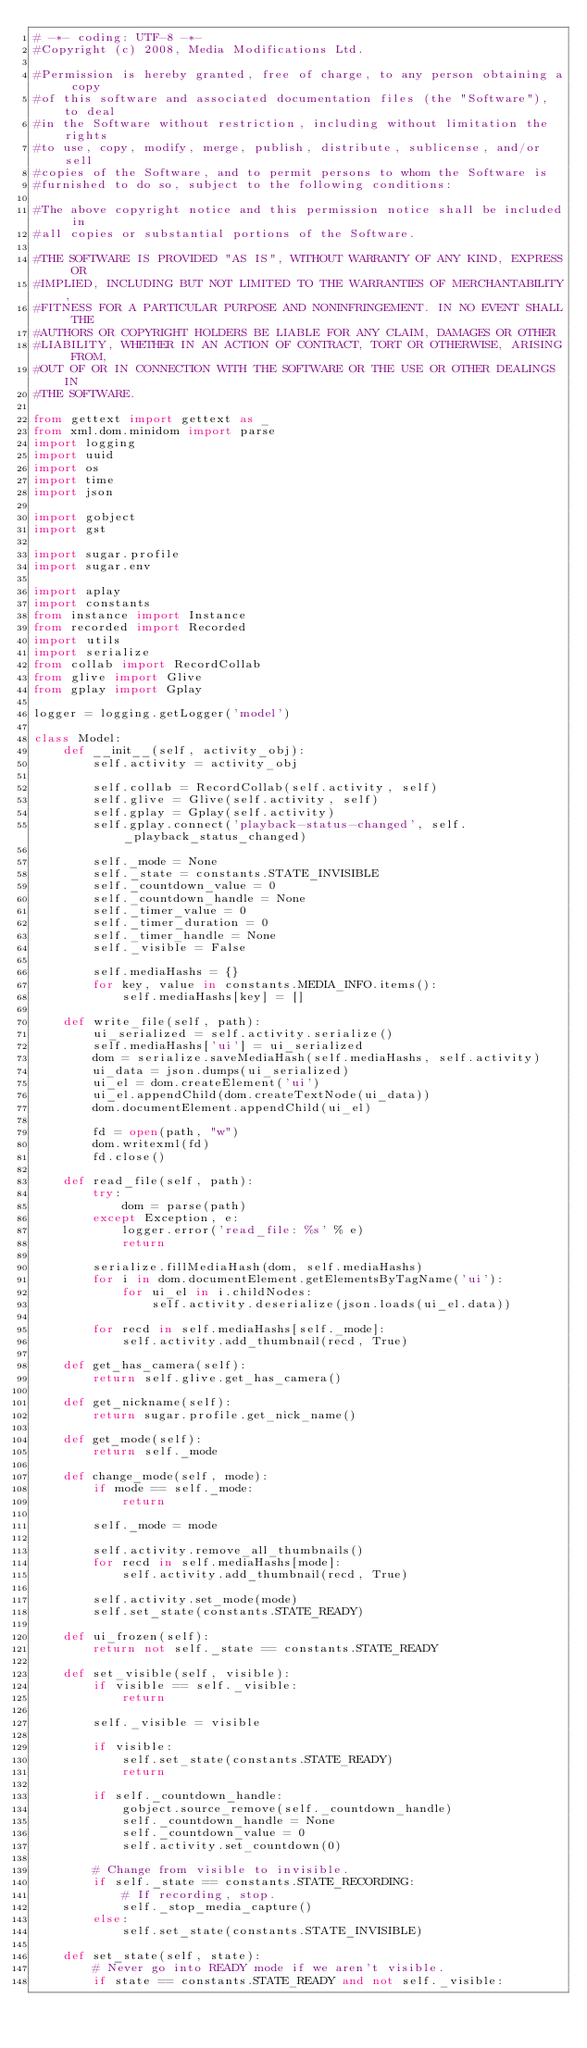Convert code to text. <code><loc_0><loc_0><loc_500><loc_500><_Python_># -*- coding: UTF-8 -*-
#Copyright (c) 2008, Media Modifications Ltd.

#Permission is hereby granted, free of charge, to any person obtaining a copy
#of this software and associated documentation files (the "Software"), to deal
#in the Software without restriction, including without limitation the rights
#to use, copy, modify, merge, publish, distribute, sublicense, and/or sell
#copies of the Software, and to permit persons to whom the Software is
#furnished to do so, subject to the following conditions:

#The above copyright notice and this permission notice shall be included in
#all copies or substantial portions of the Software.

#THE SOFTWARE IS PROVIDED "AS IS", WITHOUT WARRANTY OF ANY KIND, EXPRESS OR
#IMPLIED, INCLUDING BUT NOT LIMITED TO THE WARRANTIES OF MERCHANTABILITY,
#FITNESS FOR A PARTICULAR PURPOSE AND NONINFRINGEMENT. IN NO EVENT SHALL THE
#AUTHORS OR COPYRIGHT HOLDERS BE LIABLE FOR ANY CLAIM, DAMAGES OR OTHER
#LIABILITY, WHETHER IN AN ACTION OF CONTRACT, TORT OR OTHERWISE, ARISING FROM,
#OUT OF OR IN CONNECTION WITH THE SOFTWARE OR THE USE OR OTHER DEALINGS IN
#THE SOFTWARE.

from gettext import gettext as _
from xml.dom.minidom import parse
import logging
import uuid
import os
import time
import json

import gobject
import gst

import sugar.profile
import sugar.env

import aplay
import constants
from instance import Instance
from recorded import Recorded
import utils
import serialize
from collab import RecordCollab
from glive import Glive
from gplay import Gplay

logger = logging.getLogger('model')

class Model:
    def __init__(self, activity_obj):
        self.activity = activity_obj

        self.collab = RecordCollab(self.activity, self)
        self.glive = Glive(self.activity, self)
        self.gplay = Gplay(self.activity)
        self.gplay.connect('playback-status-changed', self._playback_status_changed)

        self._mode = None
        self._state = constants.STATE_INVISIBLE
        self._countdown_value = 0
        self._countdown_handle = None
        self._timer_value = 0
        self._timer_duration = 0
        self._timer_handle = None
        self._visible = False

        self.mediaHashs = {}
        for key, value in constants.MEDIA_INFO.items():
            self.mediaHashs[key] = []

    def write_file(self, path):
        ui_serialized = self.activity.serialize()
        self.mediaHashs['ui'] = ui_serialized
        dom = serialize.saveMediaHash(self.mediaHashs, self.activity)
        ui_data = json.dumps(ui_serialized)
        ui_el = dom.createElement('ui')
        ui_el.appendChild(dom.createTextNode(ui_data))
        dom.documentElement.appendChild(ui_el)

        fd = open(path, "w")
        dom.writexml(fd)
        fd.close()

    def read_file(self, path):
        try:
            dom = parse(path)
        except Exception, e:
            logger.error('read_file: %s' % e)
            return

        serialize.fillMediaHash(dom, self.mediaHashs)
        for i in dom.documentElement.getElementsByTagName('ui'):
            for ui_el in i.childNodes:
                self.activity.deserialize(json.loads(ui_el.data))

        for recd in self.mediaHashs[self._mode]:
            self.activity.add_thumbnail(recd, True)

    def get_has_camera(self):
        return self.glive.get_has_camera()

    def get_nickname(self):
        return sugar.profile.get_nick_name()

    def get_mode(self):
        return self._mode

    def change_mode(self, mode):
        if mode == self._mode:
            return

        self._mode = mode

        self.activity.remove_all_thumbnails()
        for recd in self.mediaHashs[mode]:
            self.activity.add_thumbnail(recd, True)

        self.activity.set_mode(mode)
        self.set_state(constants.STATE_READY)

    def ui_frozen(self):
        return not self._state == constants.STATE_READY 

    def set_visible(self, visible):
        if visible == self._visible:
            return

        self._visible = visible

        if visible:
            self.set_state(constants.STATE_READY)
            return

        if self._countdown_handle:
            gobject.source_remove(self._countdown_handle)
            self._countdown_handle = None
            self._countdown_value = 0
            self.activity.set_countdown(0)

        # Change from visible to invisible.
        if self._state == constants.STATE_RECORDING:
            # If recording, stop.
            self._stop_media_capture()
        else:
            self.set_state(constants.STATE_INVISIBLE)

    def set_state(self, state):
        # Never go into READY mode if we aren't visible.
        if state == constants.STATE_READY and not self._visible:</code> 